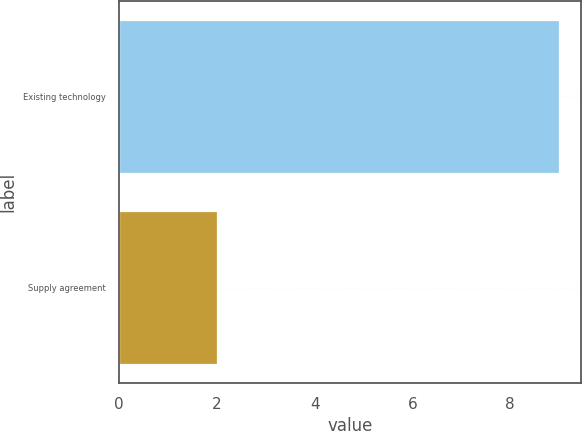Convert chart to OTSL. <chart><loc_0><loc_0><loc_500><loc_500><bar_chart><fcel>Existing technology<fcel>Supply agreement<nl><fcel>9<fcel>2<nl></chart> 